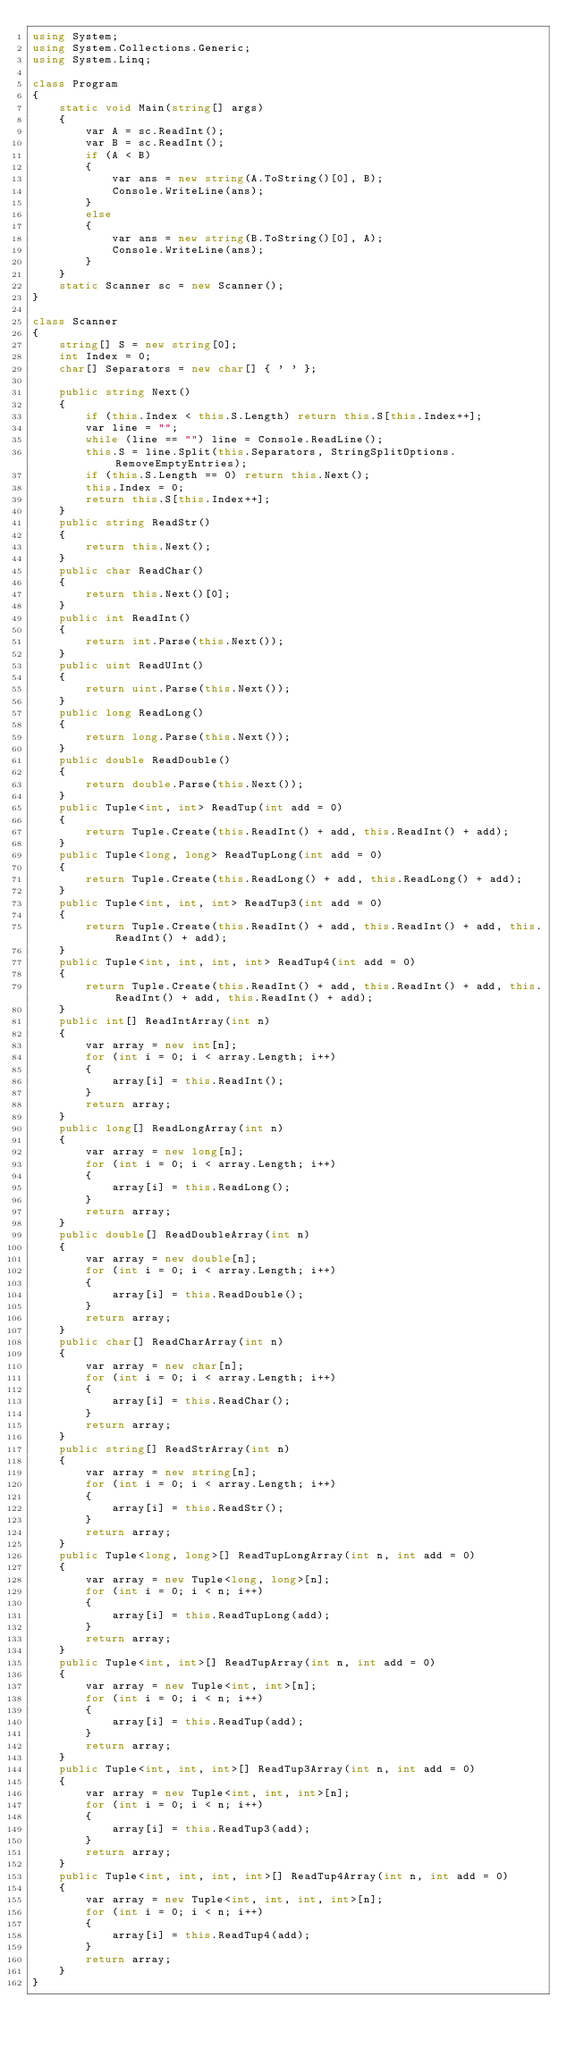<code> <loc_0><loc_0><loc_500><loc_500><_C#_>using System;
using System.Collections.Generic;
using System.Linq;

class Program
{
    static void Main(string[] args)
    {
        var A = sc.ReadInt();
        var B = sc.ReadInt();
        if (A < B)
        {
            var ans = new string(A.ToString()[0], B);
            Console.WriteLine(ans);
        }
        else
        {
            var ans = new string(B.ToString()[0], A);
            Console.WriteLine(ans);
        }
    }
    static Scanner sc = new Scanner();
}

class Scanner
{
    string[] S = new string[0];
    int Index = 0;
    char[] Separators = new char[] { ' ' };

    public string Next()
    {
        if (this.Index < this.S.Length) return this.S[this.Index++];
        var line = "";
        while (line == "") line = Console.ReadLine();
        this.S = line.Split(this.Separators, StringSplitOptions.RemoveEmptyEntries);
        if (this.S.Length == 0) return this.Next();
        this.Index = 0;
        return this.S[this.Index++];
    }
    public string ReadStr()
    {
        return this.Next();
    }
    public char ReadChar()
    {
        return this.Next()[0];
    }
    public int ReadInt()
    {
        return int.Parse(this.Next());
    }
    public uint ReadUInt()
    {
        return uint.Parse(this.Next());
    }
    public long ReadLong()
    {
        return long.Parse(this.Next());
    }
    public double ReadDouble()
    {
        return double.Parse(this.Next());
    }
    public Tuple<int, int> ReadTup(int add = 0)
    {
        return Tuple.Create(this.ReadInt() + add, this.ReadInt() + add);
    }
    public Tuple<long, long> ReadTupLong(int add = 0)
    {
        return Tuple.Create(this.ReadLong() + add, this.ReadLong() + add);
    }
    public Tuple<int, int, int> ReadTup3(int add = 0)
    {
        return Tuple.Create(this.ReadInt() + add, this.ReadInt() + add, this.ReadInt() + add);
    }
    public Tuple<int, int, int, int> ReadTup4(int add = 0)
    {
        return Tuple.Create(this.ReadInt() + add, this.ReadInt() + add, this.ReadInt() + add, this.ReadInt() + add);
    }
    public int[] ReadIntArray(int n)
    {
        var array = new int[n];
        for (int i = 0; i < array.Length; i++)
        {
            array[i] = this.ReadInt();
        }
        return array;
    }
    public long[] ReadLongArray(int n)
    {
        var array = new long[n];
        for (int i = 0; i < array.Length; i++)
        {
            array[i] = this.ReadLong();
        }
        return array;
    }
    public double[] ReadDoubleArray(int n)
    {
        var array = new double[n];
        for (int i = 0; i < array.Length; i++)
        {
            array[i] = this.ReadDouble();
        }
        return array;
    }
    public char[] ReadCharArray(int n)
    {
        var array = new char[n];
        for (int i = 0; i < array.Length; i++)
        {
            array[i] = this.ReadChar();
        }
        return array;
    }
    public string[] ReadStrArray(int n)
    {
        var array = new string[n];
        for (int i = 0; i < array.Length; i++)
        {
            array[i] = this.ReadStr();
        }
        return array;
    }
    public Tuple<long, long>[] ReadTupLongArray(int n, int add = 0)
    {
        var array = new Tuple<long, long>[n];
        for (int i = 0; i < n; i++)
        {
            array[i] = this.ReadTupLong(add);
        }
        return array;
    }
    public Tuple<int, int>[] ReadTupArray(int n, int add = 0)
    {
        var array = new Tuple<int, int>[n];
        for (int i = 0; i < n; i++)
        {
            array[i] = this.ReadTup(add);
        }
        return array;
    }
    public Tuple<int, int, int>[] ReadTup3Array(int n, int add = 0)
    {
        var array = new Tuple<int, int, int>[n];
        for (int i = 0; i < n; i++)
        {
            array[i] = this.ReadTup3(add);
        }
        return array;
    }
    public Tuple<int, int, int, int>[] ReadTup4Array(int n, int add = 0)
    {
        var array = new Tuple<int, int, int, int>[n];
        for (int i = 0; i < n; i++)
        {
            array[i] = this.ReadTup4(add);
        }
        return array;
    }
}
</code> 